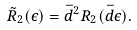Convert formula to latex. <formula><loc_0><loc_0><loc_500><loc_500>\tilde { R } _ { 2 } ( \epsilon ) = \bar { d } ^ { 2 } R _ { 2 } ( \bar { d } \epsilon ) .</formula> 